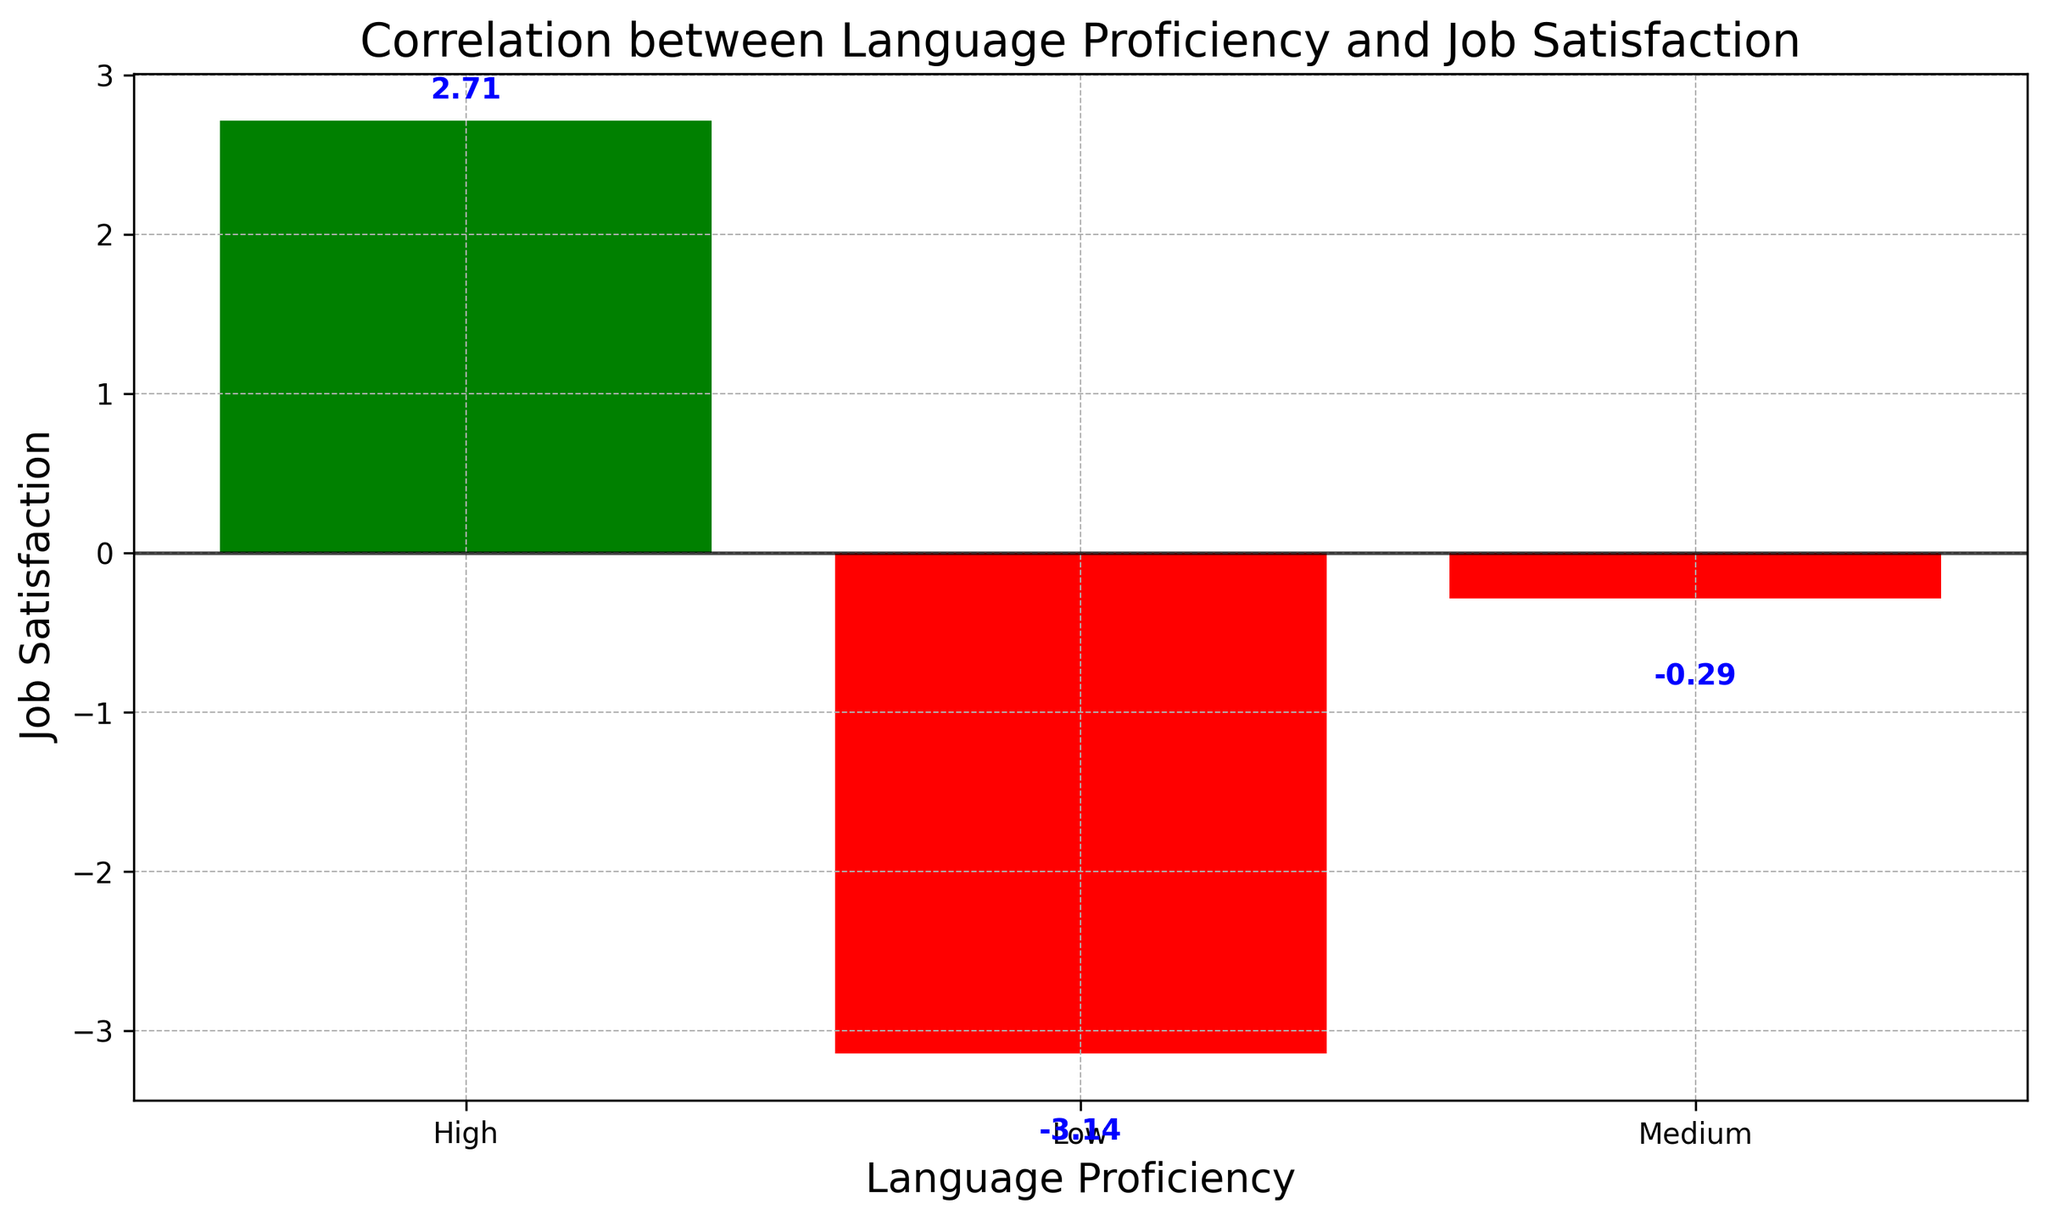What is the mean job satisfaction value for immigrants with low language proficiency? The bars represent the average job satisfaction values for each language proficiency level. The bar for "Low" language proficiency shows a value of approximately -3.
Answer: -3 Which language proficiency group has the highest average job satisfaction? The bar for the "High" language proficiency group is the tallest and colored green, indicating a positive value. This signifies it has the highest average job satisfaction.
Answer: High Are there any language proficiency groups with negative average job satisfaction? By observing the color of the bars, those colored red indicate negative values. "Low" and "Medium" proficiency groups have red bars, indicating negative average job satisfaction.
Answer: Yes, Low and Medium What is the difference in average job satisfaction between the "High" and "Low" language proficiency groups? The "High" group has a value of around 3, and the "Low" group has a value of roughly -3. The difference is 3 - (-3).
Answer: 6 What is the average job satisfaction for the "Medium" language proficiency group? The "Medium" bar shows an average job satisfaction value of approximately -0.17.
Answer: -0.17 Which language proficiency group exhibits a bar colored green, and what does this signify? The "High" language proficiency group has a green-colored bar, indicating positive job satisfaction.
Answer: High, positive job satisfaction How does the job satisfaction for the "Medium" group compare to the "Low" group? The bar for the "Medium" group is higher than the "Low" group's bar but both are negative, indicating slightly higher but still negative job satisfaction.
Answer: Higher, but still negative What is the average value of job satisfaction across all language proficiency groups? The "Low" group has an average of -3, "Medium" around -0.17, and "High" around 3. Adding these together and dividing by 3 gives the overall average. (-3 + (-0.17) + 3) / 3 = -0.057
Answer: -0.057 